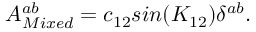Convert formula to latex. <formula><loc_0><loc_0><loc_500><loc_500>A _ { M i x e d } ^ { a b } = c _ { 1 2 } \sin ( K _ { 1 2 } ) \delta ^ { a b } .</formula> 